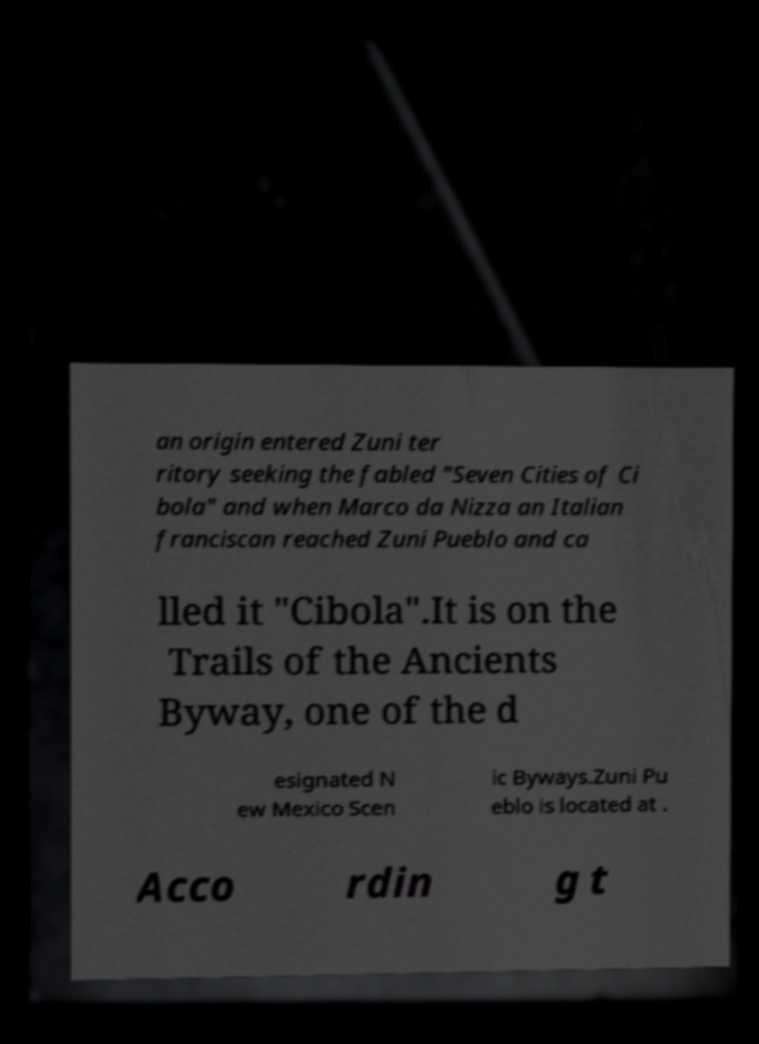Please read and relay the text visible in this image. What does it say? an origin entered Zuni ter ritory seeking the fabled "Seven Cities of Ci bola" and when Marco da Nizza an Italian franciscan reached Zuni Pueblo and ca lled it "Cibola".It is on the Trails of the Ancients Byway, one of the d esignated N ew Mexico Scen ic Byways.Zuni Pu eblo is located at . Acco rdin g t 